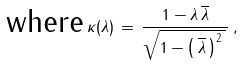<formula> <loc_0><loc_0><loc_500><loc_500>\, \text {where} \, \kappa ( \lambda ) \, = \, \frac { 1 - \lambda \, { \overline { \lambda } } } { \sqrt { 1 - \left ( \, { \overline { \lambda } } \, \right ) ^ { 2 } \, } \, } \, , \,</formula> 